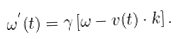<formula> <loc_0><loc_0><loc_500><loc_500>\omega ^ { ^ { \prime } } ( t ) = \gamma \left [ \omega - v ( t ) \cdot k \right ] .</formula> 